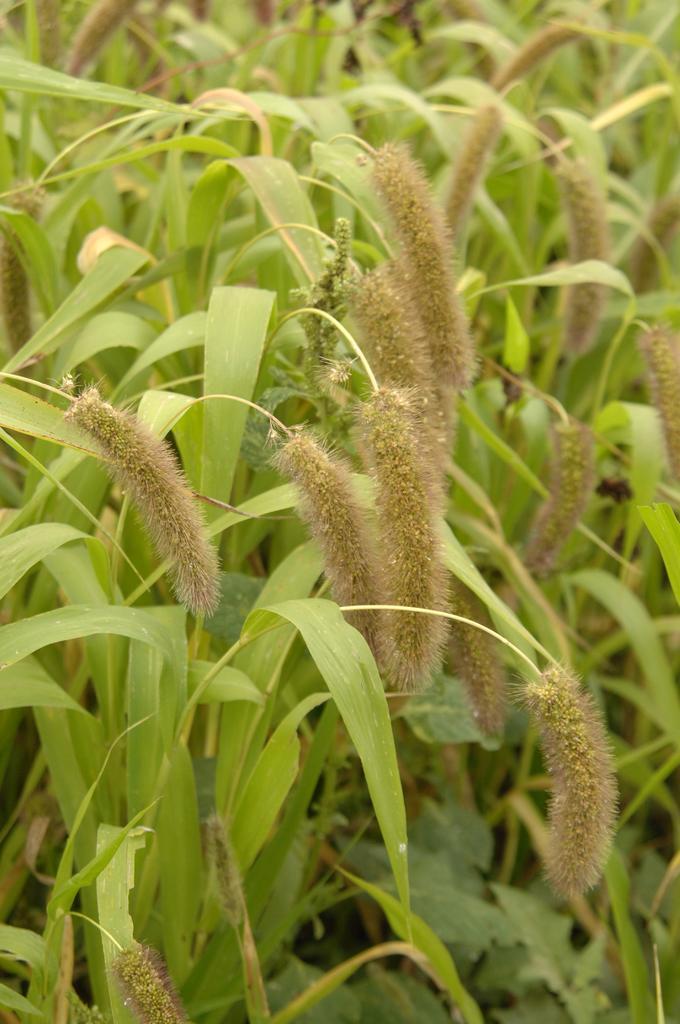Could you give a brief overview of what you see in this image? In this image we can see crops. 